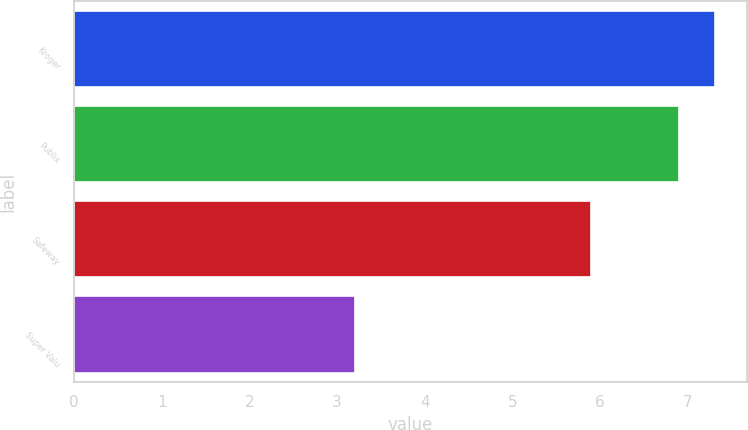Convert chart to OTSL. <chart><loc_0><loc_0><loc_500><loc_500><bar_chart><fcel>Kroger<fcel>Publix<fcel>Safeway<fcel>Super Valu<nl><fcel>7.31<fcel>6.9<fcel>5.9<fcel>3.2<nl></chart> 